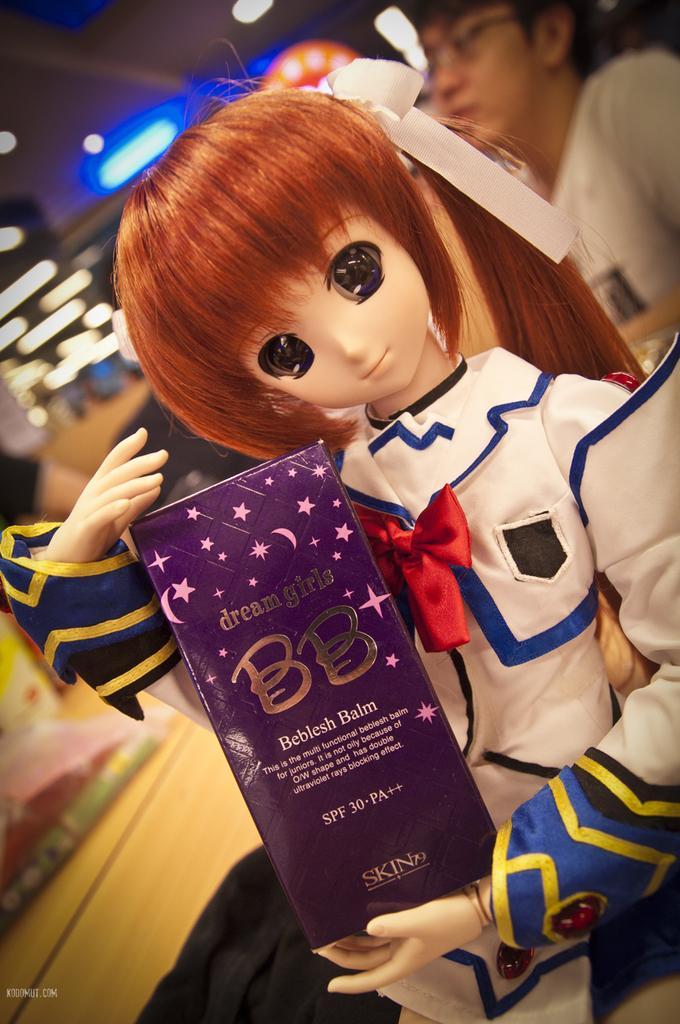Could you give a brief overview of what you see in this image? This image consists of a doll holding a blue color box. In the background, we can see a person and the light. 